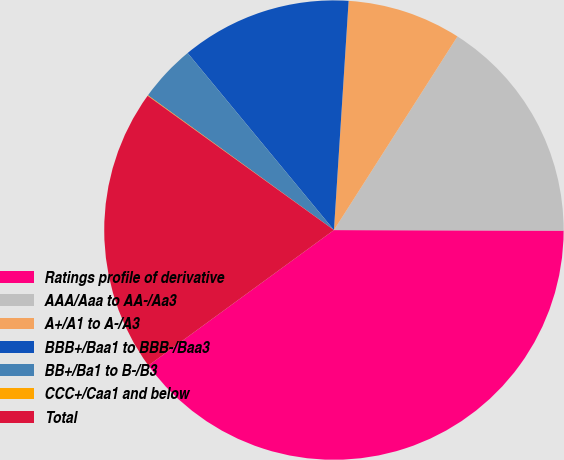<chart> <loc_0><loc_0><loc_500><loc_500><pie_chart><fcel>Ratings profile of derivative<fcel>AAA/Aaa to AA-/Aa3<fcel>A+/A1 to A-/A3<fcel>BBB+/Baa1 to BBB-/Baa3<fcel>BB+/Ba1 to B-/B3<fcel>CCC+/Caa1 and below<fcel>Total<nl><fcel>39.93%<fcel>16.0%<fcel>8.02%<fcel>12.01%<fcel>4.03%<fcel>0.04%<fcel>19.98%<nl></chart> 